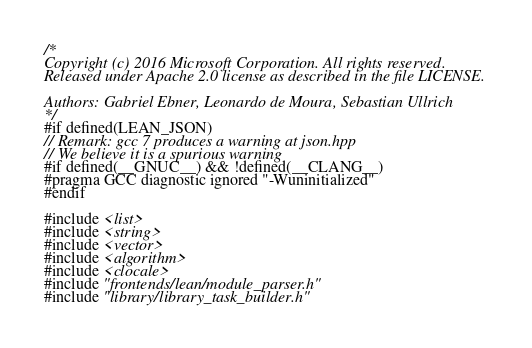<code> <loc_0><loc_0><loc_500><loc_500><_C++_>/*
Copyright (c) 2016 Microsoft Corporation. All rights reserved.
Released under Apache 2.0 license as described in the file LICENSE.

Authors: Gabriel Ebner, Leonardo de Moura, Sebastian Ullrich
*/
#if defined(LEAN_JSON)
// Remark: gcc 7 produces a warning at json.hpp
// We believe it is a spurious warning
#if defined(__GNUC__) && !defined(__CLANG__)
#pragma GCC diagnostic ignored "-Wuninitialized"
#endif

#include <list>
#include <string>
#include <vector>
#include <algorithm>
#include <clocale>
#include "frontends/lean/module_parser.h"
#include "library/library_task_builder.h"</code> 